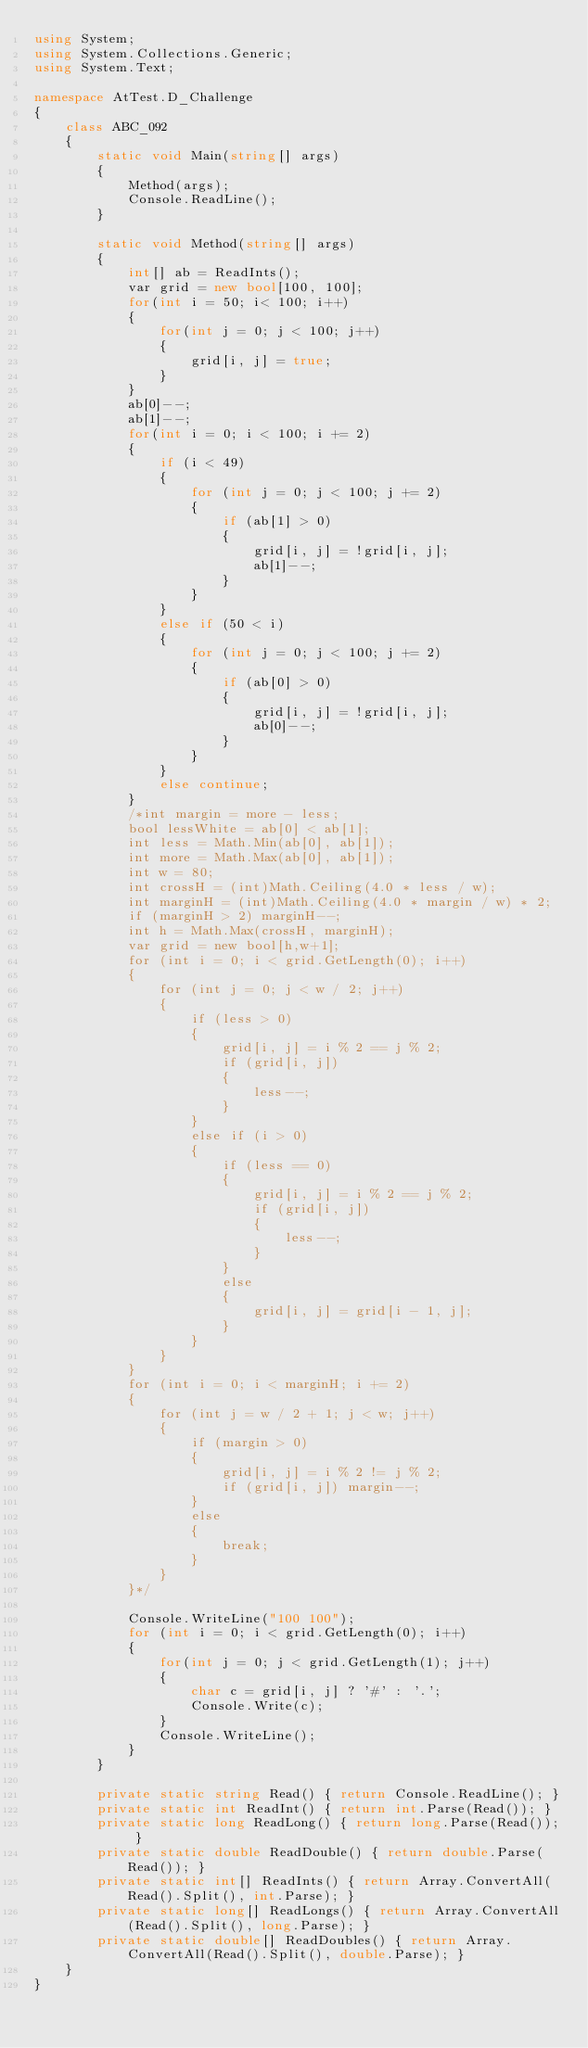Convert code to text. <code><loc_0><loc_0><loc_500><loc_500><_C#_>using System;
using System.Collections.Generic;
using System.Text;

namespace AtTest.D_Challenge
{
    class ABC_092
    {
        static void Main(string[] args)
        {
            Method(args);
            Console.ReadLine();
        }

        static void Method(string[] args)
        {
            int[] ab = ReadInts();
            var grid = new bool[100, 100];
            for(int i = 50; i< 100; i++)
            {
                for(int j = 0; j < 100; j++)
                {
                    grid[i, j] = true;
                }
            }
            ab[0]--;
            ab[1]--;
            for(int i = 0; i < 100; i += 2)
            {
                if (i < 49)
                {
                    for (int j = 0; j < 100; j += 2)
                    {
                        if (ab[1] > 0)
                        {
                            grid[i, j] = !grid[i, j];
                            ab[1]--;
                        }
                    }
                }
                else if (50 < i)
                {
                    for (int j = 0; j < 100; j += 2)
                    {
                        if (ab[0] > 0)
                        {
                            grid[i, j] = !grid[i, j];
                            ab[0]--;
                        }
                    }
                }
                else continue;
            }
            /*int margin = more - less;
            bool lessWhite = ab[0] < ab[1];
            int less = Math.Min(ab[0], ab[1]);
            int more = Math.Max(ab[0], ab[1]);
            int w = 80;
            int crossH = (int)Math.Ceiling(4.0 * less / w);
            int marginH = (int)Math.Ceiling(4.0 * margin / w) * 2;
            if (marginH > 2) marginH--;
            int h = Math.Max(crossH, marginH);
            var grid = new bool[h,w+1];
            for (int i = 0; i < grid.GetLength(0); i++)
            {
                for (int j = 0; j < w / 2; j++)
                {
                    if (less > 0)
                    {
                        grid[i, j] = i % 2 == j % 2;
                        if (grid[i, j])
                        {
                            less--;
                        }
                    }
                    else if (i > 0)
                    {
                        if (less == 0)
                        {
                            grid[i, j] = i % 2 == j % 2;
                            if (grid[i, j])
                            {
                                less--;
                            }
                        }
                        else
                        {
                            grid[i, j] = grid[i - 1, j];
                        }
                    }
                }
            }
            for (int i = 0; i < marginH; i += 2)
            {
                for (int j = w / 2 + 1; j < w; j++)
                {
                    if (margin > 0)
                    {
                        grid[i, j] = i % 2 != j % 2;
                        if (grid[i, j]) margin--;
                    }
                    else
                    {
                        break;
                    }
                }
            }*/

            Console.WriteLine("100 100");
            for (int i = 0; i < grid.GetLength(0); i++)
            {
                for(int j = 0; j < grid.GetLength(1); j++)
                {
                    char c = grid[i, j] ? '#' : '.';
                    Console.Write(c);
                }
                Console.WriteLine();
            }
        }

        private static string Read() { return Console.ReadLine(); }
        private static int ReadInt() { return int.Parse(Read()); }
        private static long ReadLong() { return long.Parse(Read()); }
        private static double ReadDouble() { return double.Parse(Read()); }
        private static int[] ReadInts() { return Array.ConvertAll(Read().Split(), int.Parse); }
        private static long[] ReadLongs() { return Array.ConvertAll(Read().Split(), long.Parse); }
        private static double[] ReadDoubles() { return Array.ConvertAll(Read().Split(), double.Parse); }
    }
}
</code> 